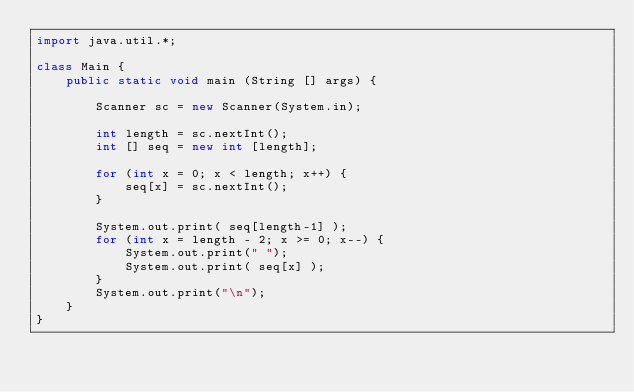<code> <loc_0><loc_0><loc_500><loc_500><_Java_>import java.util.*;

class Main {
    public static void main (String [] args) {

        Scanner sc = new Scanner(System.in);

        int length = sc.nextInt();
        int [] seq = new int [length];

        for (int x = 0; x < length; x++) {
            seq[x] = sc.nextInt();
        }

        System.out.print( seq[length-1] );
        for (int x = length - 2; x >= 0; x--) {
            System.out.print(" ");
            System.out.print( seq[x] );
        }
        System.out.print("\n");
    }
}</code> 